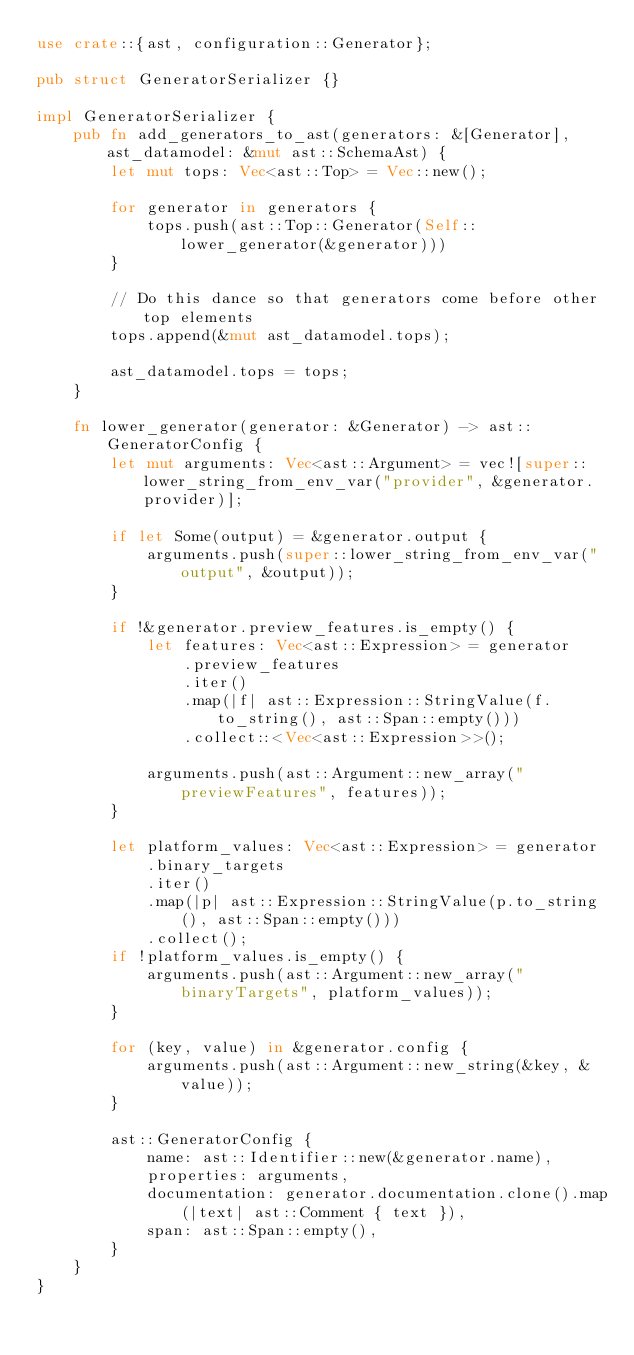<code> <loc_0><loc_0><loc_500><loc_500><_Rust_>use crate::{ast, configuration::Generator};

pub struct GeneratorSerializer {}

impl GeneratorSerializer {
    pub fn add_generators_to_ast(generators: &[Generator], ast_datamodel: &mut ast::SchemaAst) {
        let mut tops: Vec<ast::Top> = Vec::new();

        for generator in generators {
            tops.push(ast::Top::Generator(Self::lower_generator(&generator)))
        }

        // Do this dance so that generators come before other top elements
        tops.append(&mut ast_datamodel.tops);

        ast_datamodel.tops = tops;
    }

    fn lower_generator(generator: &Generator) -> ast::GeneratorConfig {
        let mut arguments: Vec<ast::Argument> = vec![super::lower_string_from_env_var("provider", &generator.provider)];

        if let Some(output) = &generator.output {
            arguments.push(super::lower_string_from_env_var("output", &output));
        }

        if !&generator.preview_features.is_empty() {
            let features: Vec<ast::Expression> = generator
                .preview_features
                .iter()
                .map(|f| ast::Expression::StringValue(f.to_string(), ast::Span::empty()))
                .collect::<Vec<ast::Expression>>();

            arguments.push(ast::Argument::new_array("previewFeatures", features));
        }

        let platform_values: Vec<ast::Expression> = generator
            .binary_targets
            .iter()
            .map(|p| ast::Expression::StringValue(p.to_string(), ast::Span::empty()))
            .collect();
        if !platform_values.is_empty() {
            arguments.push(ast::Argument::new_array("binaryTargets", platform_values));
        }

        for (key, value) in &generator.config {
            arguments.push(ast::Argument::new_string(&key, &value));
        }

        ast::GeneratorConfig {
            name: ast::Identifier::new(&generator.name),
            properties: arguments,
            documentation: generator.documentation.clone().map(|text| ast::Comment { text }),
            span: ast::Span::empty(),
        }
    }
}
</code> 